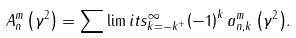<formula> <loc_0><loc_0><loc_500><loc_500>A _ { n } ^ { m } \left ( { \gamma ^ { 2 } } \right ) = \sum \lim i t s _ { k = - k ^ { + } } ^ { \infty } { \left ( { - 1 } \right ) ^ { k } a _ { n , k } ^ { m } \left ( { \gamma ^ { 2 } } \right ) } .</formula> 